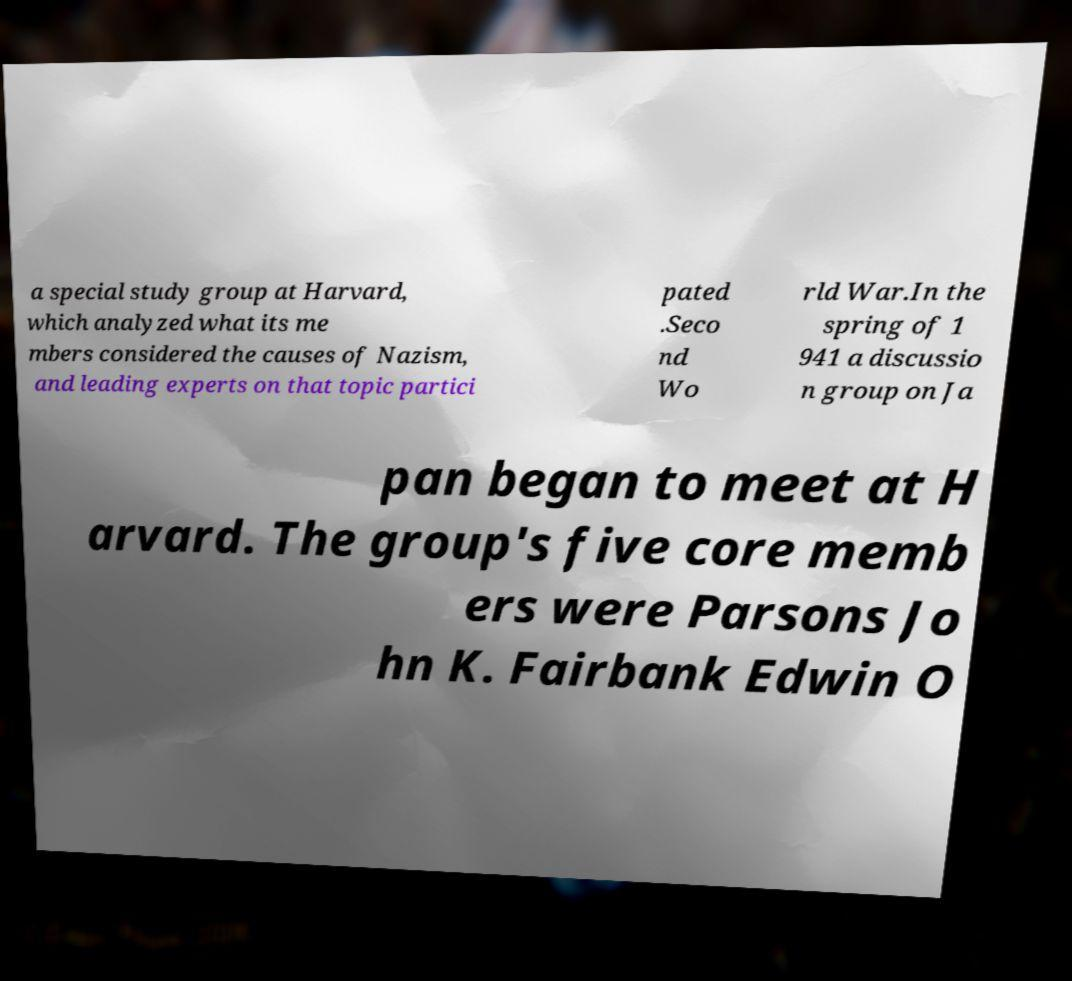I need the written content from this picture converted into text. Can you do that? a special study group at Harvard, which analyzed what its me mbers considered the causes of Nazism, and leading experts on that topic partici pated .Seco nd Wo rld War.In the spring of 1 941 a discussio n group on Ja pan began to meet at H arvard. The group's five core memb ers were Parsons Jo hn K. Fairbank Edwin O 